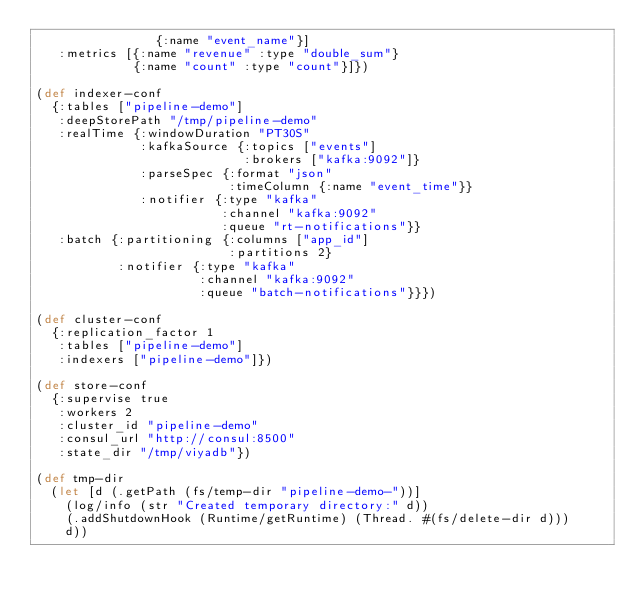Convert code to text. <code><loc_0><loc_0><loc_500><loc_500><_Clojure_>                {:name "event_name"}]
   :metrics [{:name "revenue" :type "double_sum"}
             {:name "count" :type "count"}]})

(def indexer-conf 
  {:tables ["pipeline-demo"]
   :deepStorePath "/tmp/pipeline-demo"
   :realTime {:windowDuration "PT30S"
              :kafkaSource {:topics ["events"]
                            :brokers ["kafka:9092"]}
              :parseSpec {:format "json"
                          :timeColumn {:name "event_time"}}
              :notifier {:type "kafka"
                         :channel "kafka:9092"
                         :queue "rt-notifications"}}
   :batch {:partitioning {:columns ["app_id"]
                          :partitions 2}
           :notifier {:type "kafka"
                      :channel "kafka:9092"
                      :queue "batch-notifications"}}})

(def cluster-conf 
  {:replication_factor 1
   :tables ["pipeline-demo"]
   :indexers ["pipeline-demo"]})

(def store-conf
  {:supervise true
   :workers 2
   :cluster_id "pipeline-demo"
   :consul_url "http://consul:8500"
   :state_dir "/tmp/viyadb"})

(def tmp-dir
  (let [d (.getPath (fs/temp-dir "pipeline-demo-"))]
    (log/info (str "Created temporary directory:" d))
    (.addShutdownHook (Runtime/getRuntime) (Thread. #(fs/delete-dir d)))
    d))
</code> 